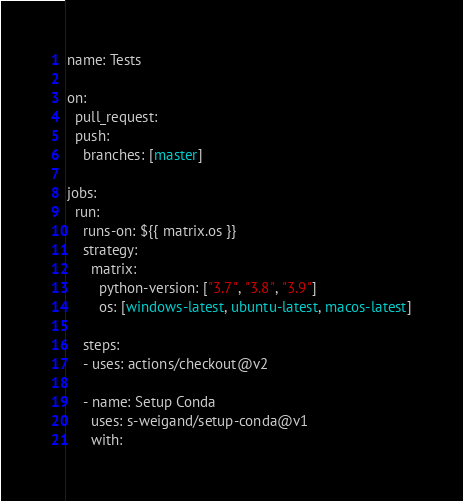<code> <loc_0><loc_0><loc_500><loc_500><_YAML_>name: Tests

on:
  pull_request:
  push:
    branches: [master]

jobs:
  run:
    runs-on: ${{ matrix.os }}
    strategy:
      matrix:
        python-version: ["3.7", "3.8", "3.9"]
        os: [windows-latest, ubuntu-latest, macos-latest]

    steps:
    - uses: actions/checkout@v2

    - name: Setup Conda
      uses: s-weigand/setup-conda@v1
      with:</code> 